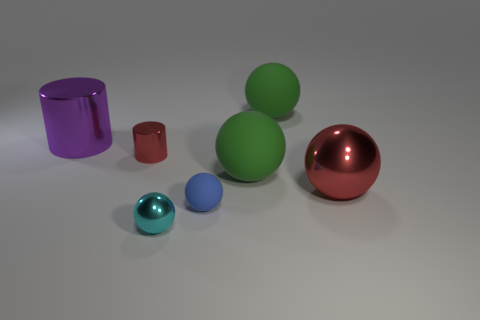What is the shape of the big thing that is the same color as the small cylinder?
Provide a short and direct response. Sphere. There is a sphere that is the same color as the small metal cylinder; what is its size?
Keep it short and to the point. Large. The tiny shiny object that is in front of the metal ball to the right of the sphere that is in front of the tiny rubber thing is what shape?
Give a very brief answer. Sphere. Do the red ball and the cyan thing have the same size?
Offer a terse response. No. What number of objects are blue matte objects or balls that are behind the large red ball?
Your answer should be very brief. 3. What number of things are either tiny shiny things that are on the right side of the tiny red cylinder or tiny metal objects right of the red cylinder?
Make the answer very short. 1. Are there any balls behind the big red metal sphere?
Offer a very short reply. Yes. What is the color of the large matte object in front of the big green thing on the right side of the large green object in front of the large cylinder?
Offer a very short reply. Green. Is the shape of the big purple object the same as the small red metallic thing?
Ensure brevity in your answer.  Yes. There is a cylinder that is the same material as the small red thing; what is its color?
Provide a short and direct response. Purple. 